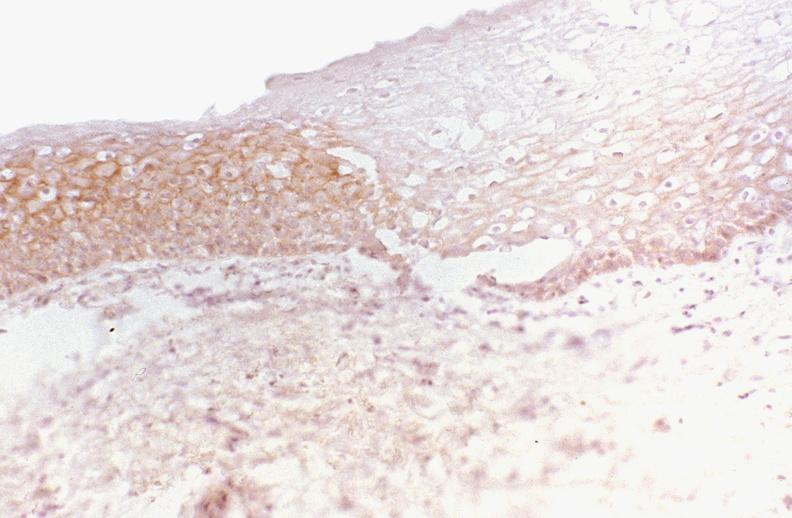what is present?
Answer the question using a single word or phrase. Gastrointestinal 